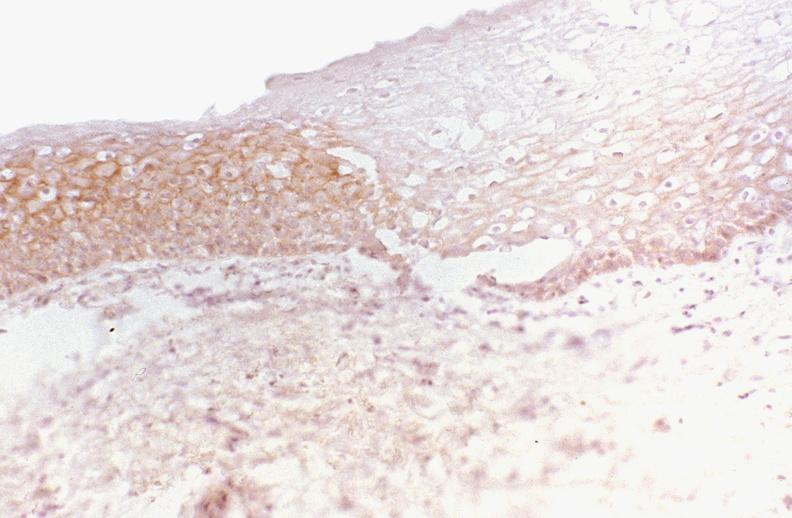what is present?
Answer the question using a single word or phrase. Gastrointestinal 